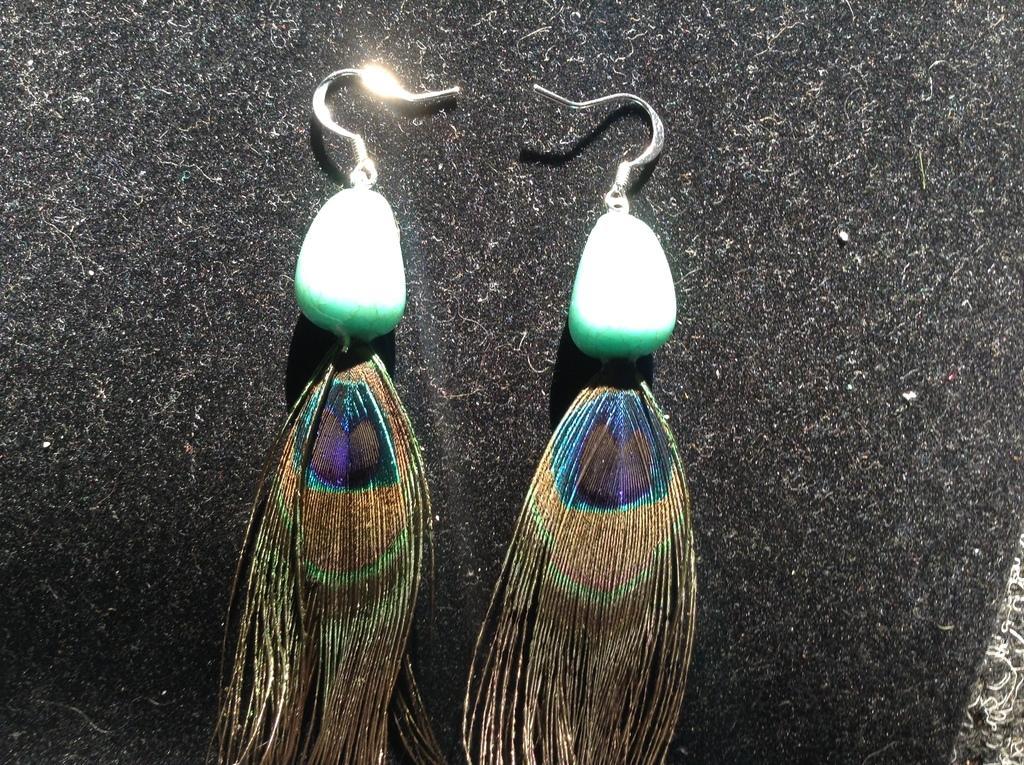Describe this image in one or two sentences. In this picture we can see earrings, in the background there is sponge. 